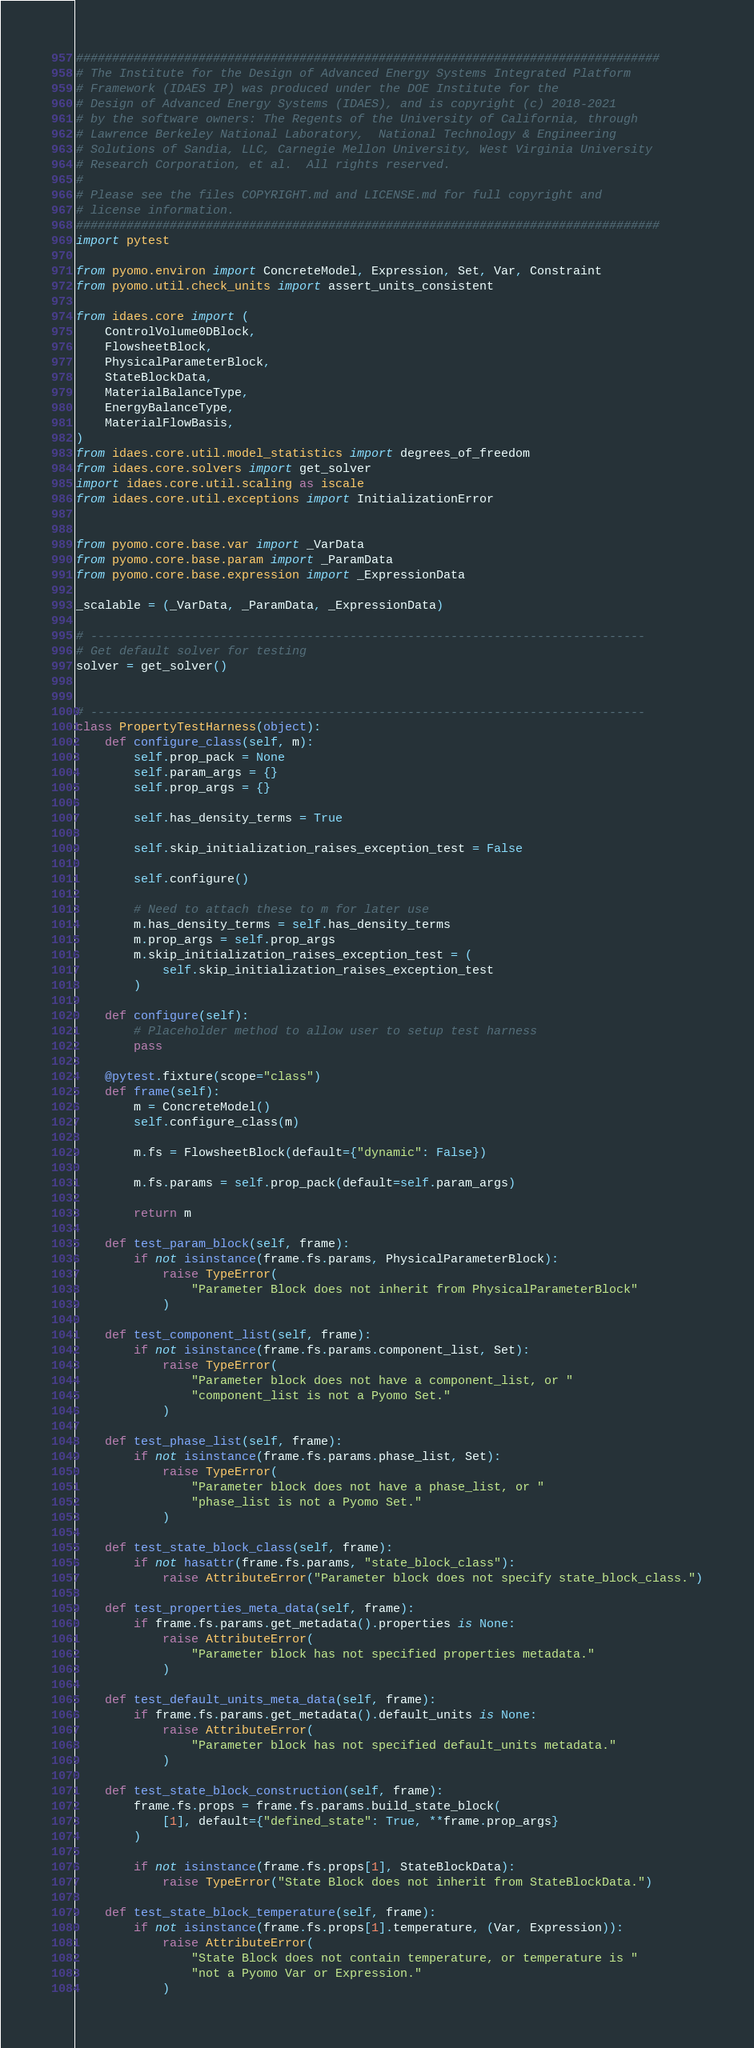<code> <loc_0><loc_0><loc_500><loc_500><_Python_>#################################################################################
# The Institute for the Design of Advanced Energy Systems Integrated Platform
# Framework (IDAES IP) was produced under the DOE Institute for the
# Design of Advanced Energy Systems (IDAES), and is copyright (c) 2018-2021
# by the software owners: The Regents of the University of California, through
# Lawrence Berkeley National Laboratory,  National Technology & Engineering
# Solutions of Sandia, LLC, Carnegie Mellon University, West Virginia University
# Research Corporation, et al.  All rights reserved.
#
# Please see the files COPYRIGHT.md and LICENSE.md for full copyright and
# license information.
#################################################################################
import pytest

from pyomo.environ import ConcreteModel, Expression, Set, Var, Constraint
from pyomo.util.check_units import assert_units_consistent

from idaes.core import (
    ControlVolume0DBlock,
    FlowsheetBlock,
    PhysicalParameterBlock,
    StateBlockData,
    MaterialBalanceType,
    EnergyBalanceType,
    MaterialFlowBasis,
)
from idaes.core.util.model_statistics import degrees_of_freedom
from idaes.core.solvers import get_solver
import idaes.core.util.scaling as iscale
from idaes.core.util.exceptions import InitializationError


from pyomo.core.base.var import _VarData
from pyomo.core.base.param import _ParamData
from pyomo.core.base.expression import _ExpressionData

_scalable = (_VarData, _ParamData, _ExpressionData)

# -----------------------------------------------------------------------------
# Get default solver for testing
solver = get_solver()


# -----------------------------------------------------------------------------
class PropertyTestHarness(object):
    def configure_class(self, m):
        self.prop_pack = None
        self.param_args = {}
        self.prop_args = {}

        self.has_density_terms = True

        self.skip_initialization_raises_exception_test = False

        self.configure()

        # Need to attach these to m for later use
        m.has_density_terms = self.has_density_terms
        m.prop_args = self.prop_args
        m.skip_initialization_raises_exception_test = (
            self.skip_initialization_raises_exception_test
        )

    def configure(self):
        # Placeholder method to allow user to setup test harness
        pass

    @pytest.fixture(scope="class")
    def frame(self):
        m = ConcreteModel()
        self.configure_class(m)

        m.fs = FlowsheetBlock(default={"dynamic": False})

        m.fs.params = self.prop_pack(default=self.param_args)

        return m

    def test_param_block(self, frame):
        if not isinstance(frame.fs.params, PhysicalParameterBlock):
            raise TypeError(
                "Parameter Block does not inherit from PhysicalParameterBlock"
            )

    def test_component_list(self, frame):
        if not isinstance(frame.fs.params.component_list, Set):
            raise TypeError(
                "Parameter block does not have a component_list, or "
                "component_list is not a Pyomo Set."
            )

    def test_phase_list(self, frame):
        if not isinstance(frame.fs.params.phase_list, Set):
            raise TypeError(
                "Parameter block does not have a phase_list, or "
                "phase_list is not a Pyomo Set."
            )

    def test_state_block_class(self, frame):
        if not hasattr(frame.fs.params, "state_block_class"):
            raise AttributeError("Parameter block does not specify state_block_class.")

    def test_properties_meta_data(self, frame):
        if frame.fs.params.get_metadata().properties is None:
            raise AttributeError(
                "Parameter block has not specified properties metadata."
            )

    def test_default_units_meta_data(self, frame):
        if frame.fs.params.get_metadata().default_units is None:
            raise AttributeError(
                "Parameter block has not specified default_units metadata."
            )

    def test_state_block_construction(self, frame):
        frame.fs.props = frame.fs.params.build_state_block(
            [1], default={"defined_state": True, **frame.prop_args}
        )

        if not isinstance(frame.fs.props[1], StateBlockData):
            raise TypeError("State Block does not inherit from StateBlockData.")

    def test_state_block_temperature(self, frame):
        if not isinstance(frame.fs.props[1].temperature, (Var, Expression)):
            raise AttributeError(
                "State Block does not contain temperature, or temperature is "
                "not a Pyomo Var or Expression."
            )
</code> 